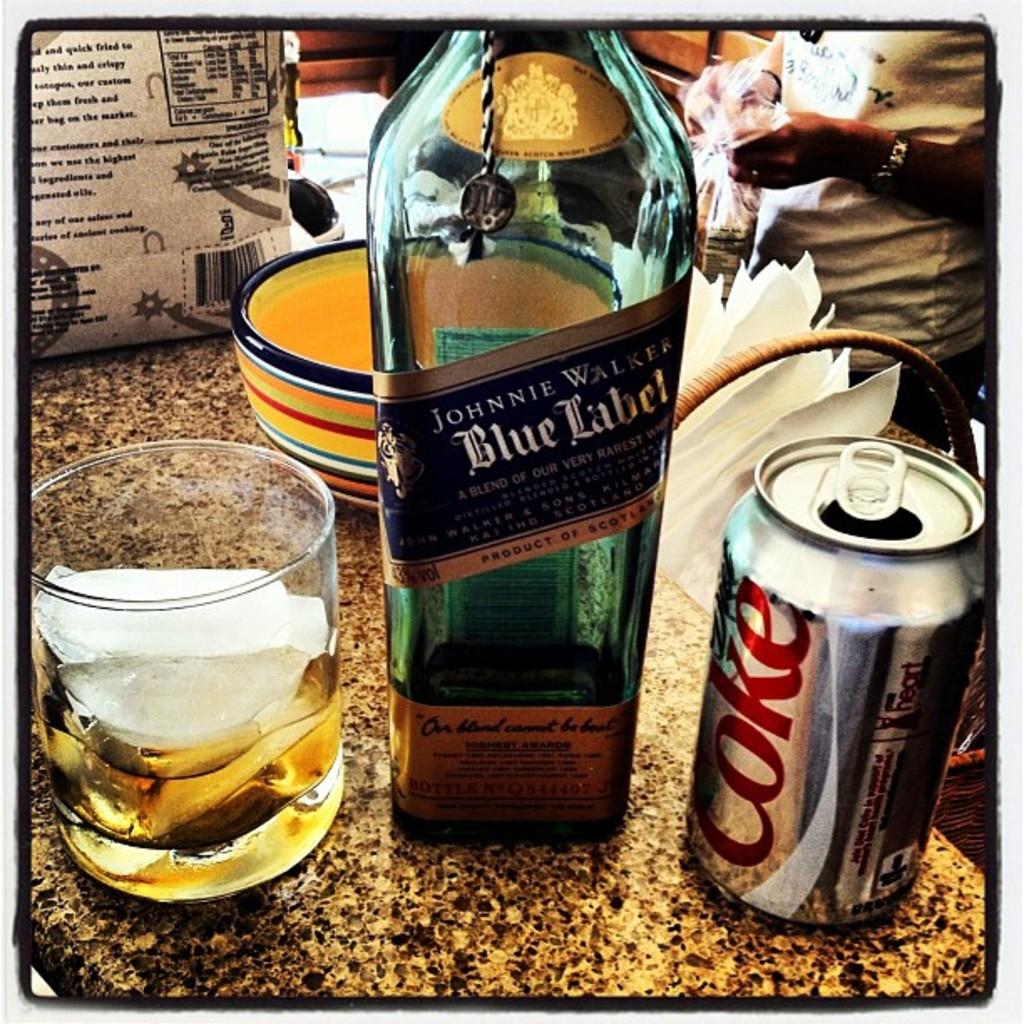What label is this "johnnie walker"?
Make the answer very short. Blue. What soda brand is printed on the can?
Your answer should be very brief. Coke. 